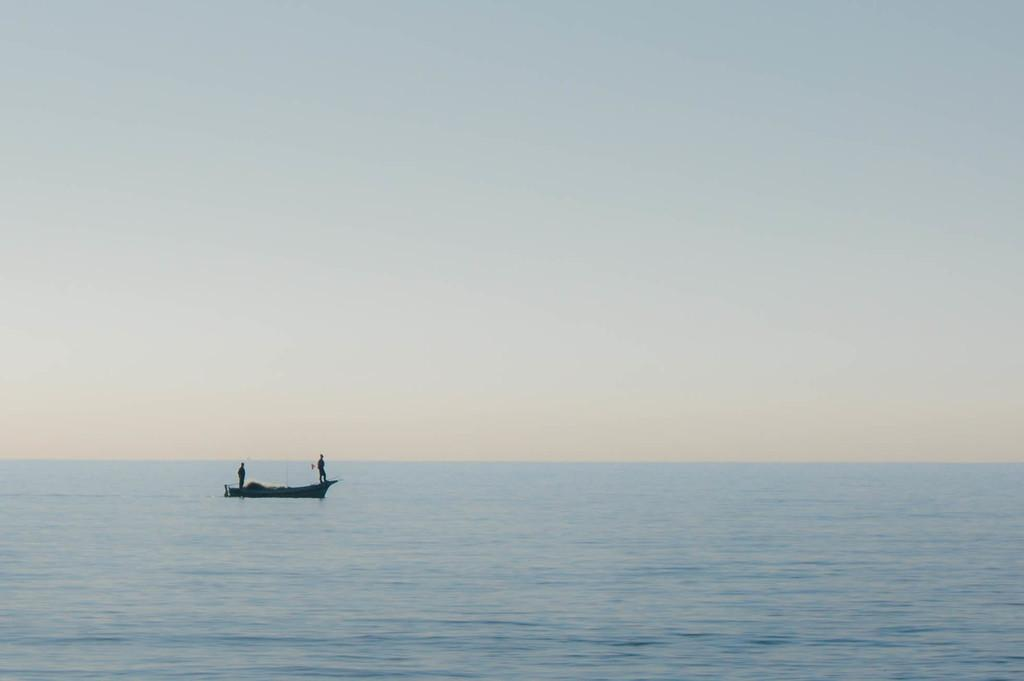How many people are in the image? There are two men in the image. What are the men doing in the image? The men are standing in a boat. What type of water is visible in the image? There is sea water visible in the image. What else can be seen in the image besides the boat and the men? The sky is visible in the image. What type of pen is the giraffe holding in the image? There is no giraffe or pen present in the image. 